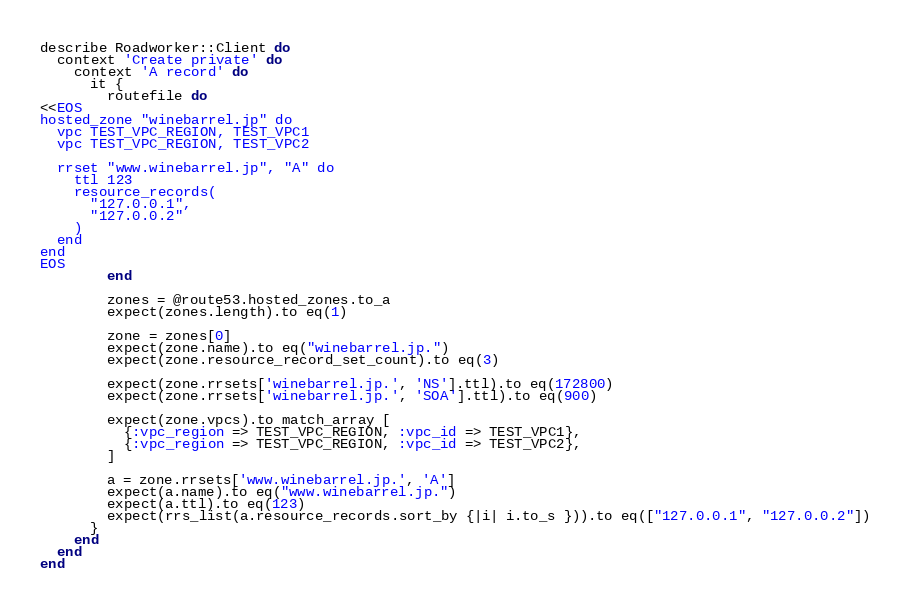Convert code to text. <code><loc_0><loc_0><loc_500><loc_500><_Ruby_>describe Roadworker::Client do
  context 'Create private' do
    context 'A record' do
      it {
        routefile do
<<EOS
hosted_zone "winebarrel.jp" do
  vpc TEST_VPC_REGION, TEST_VPC1
  vpc TEST_VPC_REGION, TEST_VPC2

  rrset "www.winebarrel.jp", "A" do
    ttl 123
    resource_records(
      "127.0.0.1",
      "127.0.0.2"
    )
  end
end
EOS
        end

        zones = @route53.hosted_zones.to_a
        expect(zones.length).to eq(1)

        zone = zones[0]
        expect(zone.name).to eq("winebarrel.jp.")
        expect(zone.resource_record_set_count).to eq(3)

        expect(zone.rrsets['winebarrel.jp.', 'NS'].ttl).to eq(172800)
        expect(zone.rrsets['winebarrel.jp.', 'SOA'].ttl).to eq(900)

        expect(zone.vpcs).to match_array [
          {:vpc_region => TEST_VPC_REGION, :vpc_id => TEST_VPC1},
          {:vpc_region => TEST_VPC_REGION, :vpc_id => TEST_VPC2},
        ]

        a = zone.rrsets['www.winebarrel.jp.', 'A']
        expect(a.name).to eq("www.winebarrel.jp.")
        expect(a.ttl).to eq(123)
        expect(rrs_list(a.resource_records.sort_by {|i| i.to_s })).to eq(["127.0.0.1", "127.0.0.2"])
      }
    end
  end
end
</code> 